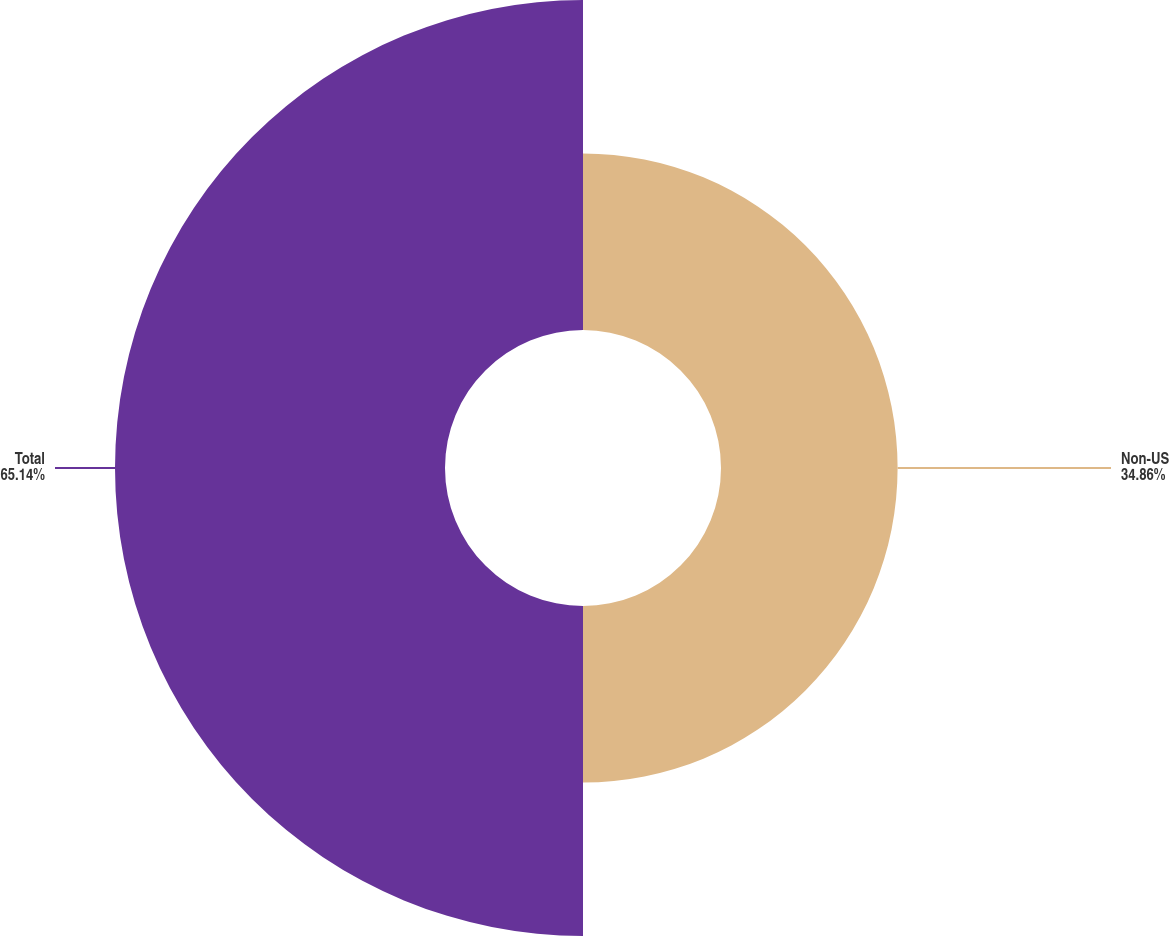<chart> <loc_0><loc_0><loc_500><loc_500><pie_chart><fcel>Non-US<fcel>Total<nl><fcel>34.86%<fcel>65.14%<nl></chart> 